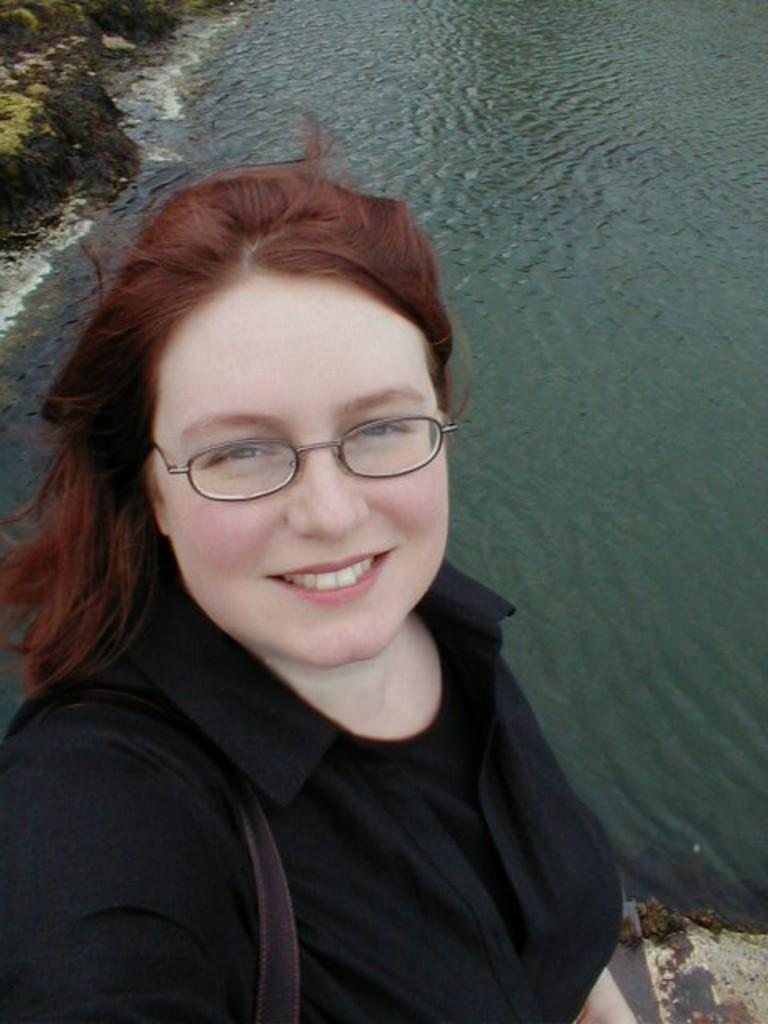Who is present in the image? There is a lady in the image. What is the lady doing in the image? The lady is smiling in the image. What is the lady wearing in the image? The lady is wearing a black shirt in the image. What can be seen in the background of the image? Water and rocks are visible in the background of the image. What type of coal can be seen in the lady's hand in the image? There is no coal present in the image, and the lady's hands are not visible. 